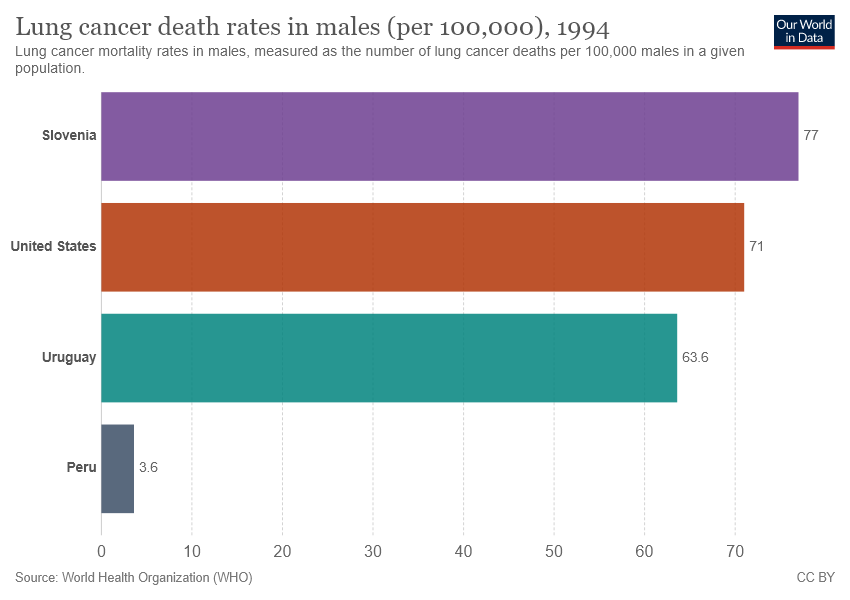Give some essential details in this illustration. There are 4 color bars in the graph. 